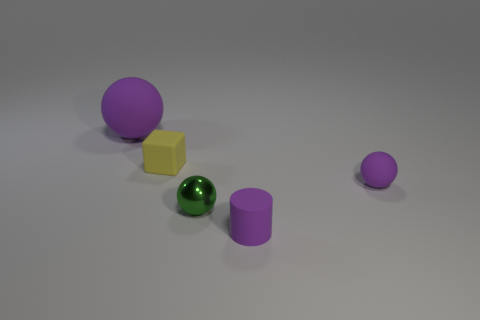The tiny yellow thing that is made of the same material as the big purple sphere is what shape?
Provide a succinct answer. Cube. Is the number of small purple balls left of the matte cylinder less than the number of blue balls?
Make the answer very short. No. Is the yellow thing the same shape as the shiny object?
Offer a terse response. No. What number of shiny objects are yellow things or gray spheres?
Offer a terse response. 0. Is there a green metal sphere of the same size as the green shiny thing?
Your response must be concise. No. The tiny thing that is the same color as the tiny rubber ball is what shape?
Give a very brief answer. Cylinder. How many gray rubber spheres have the same size as the rubber block?
Provide a short and direct response. 0. Does the purple ball that is to the right of the matte cube have the same size as the sphere that is left of the tiny shiny object?
Give a very brief answer. No. How many things are either big gray rubber cylinders or small matte things that are in front of the matte block?
Give a very brief answer. 2. What is the color of the tiny metallic ball?
Your answer should be compact. Green. 